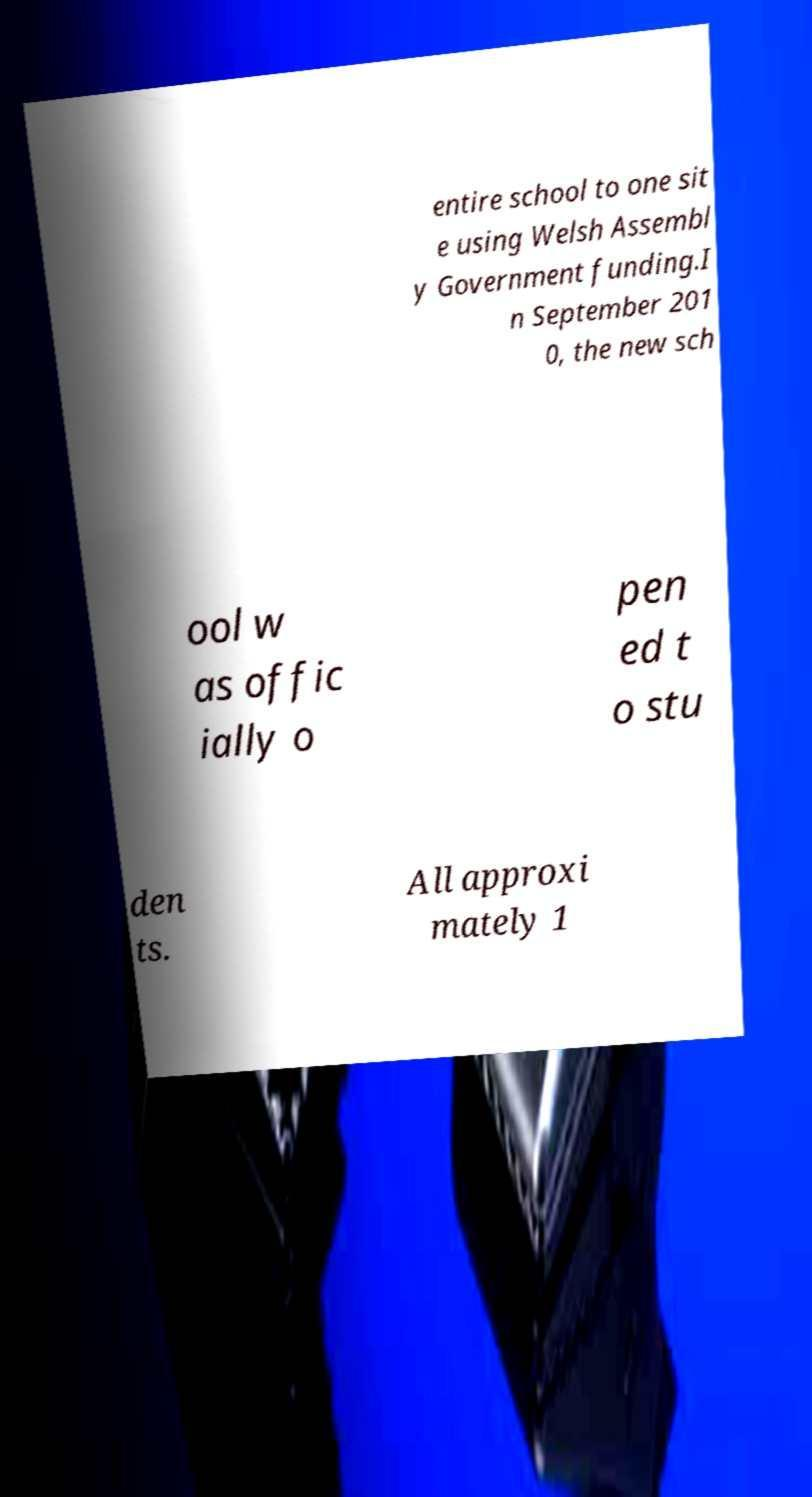Please read and relay the text visible in this image. What does it say? entire school to one sit e using Welsh Assembl y Government funding.I n September 201 0, the new sch ool w as offic ially o pen ed t o stu den ts. All approxi mately 1 